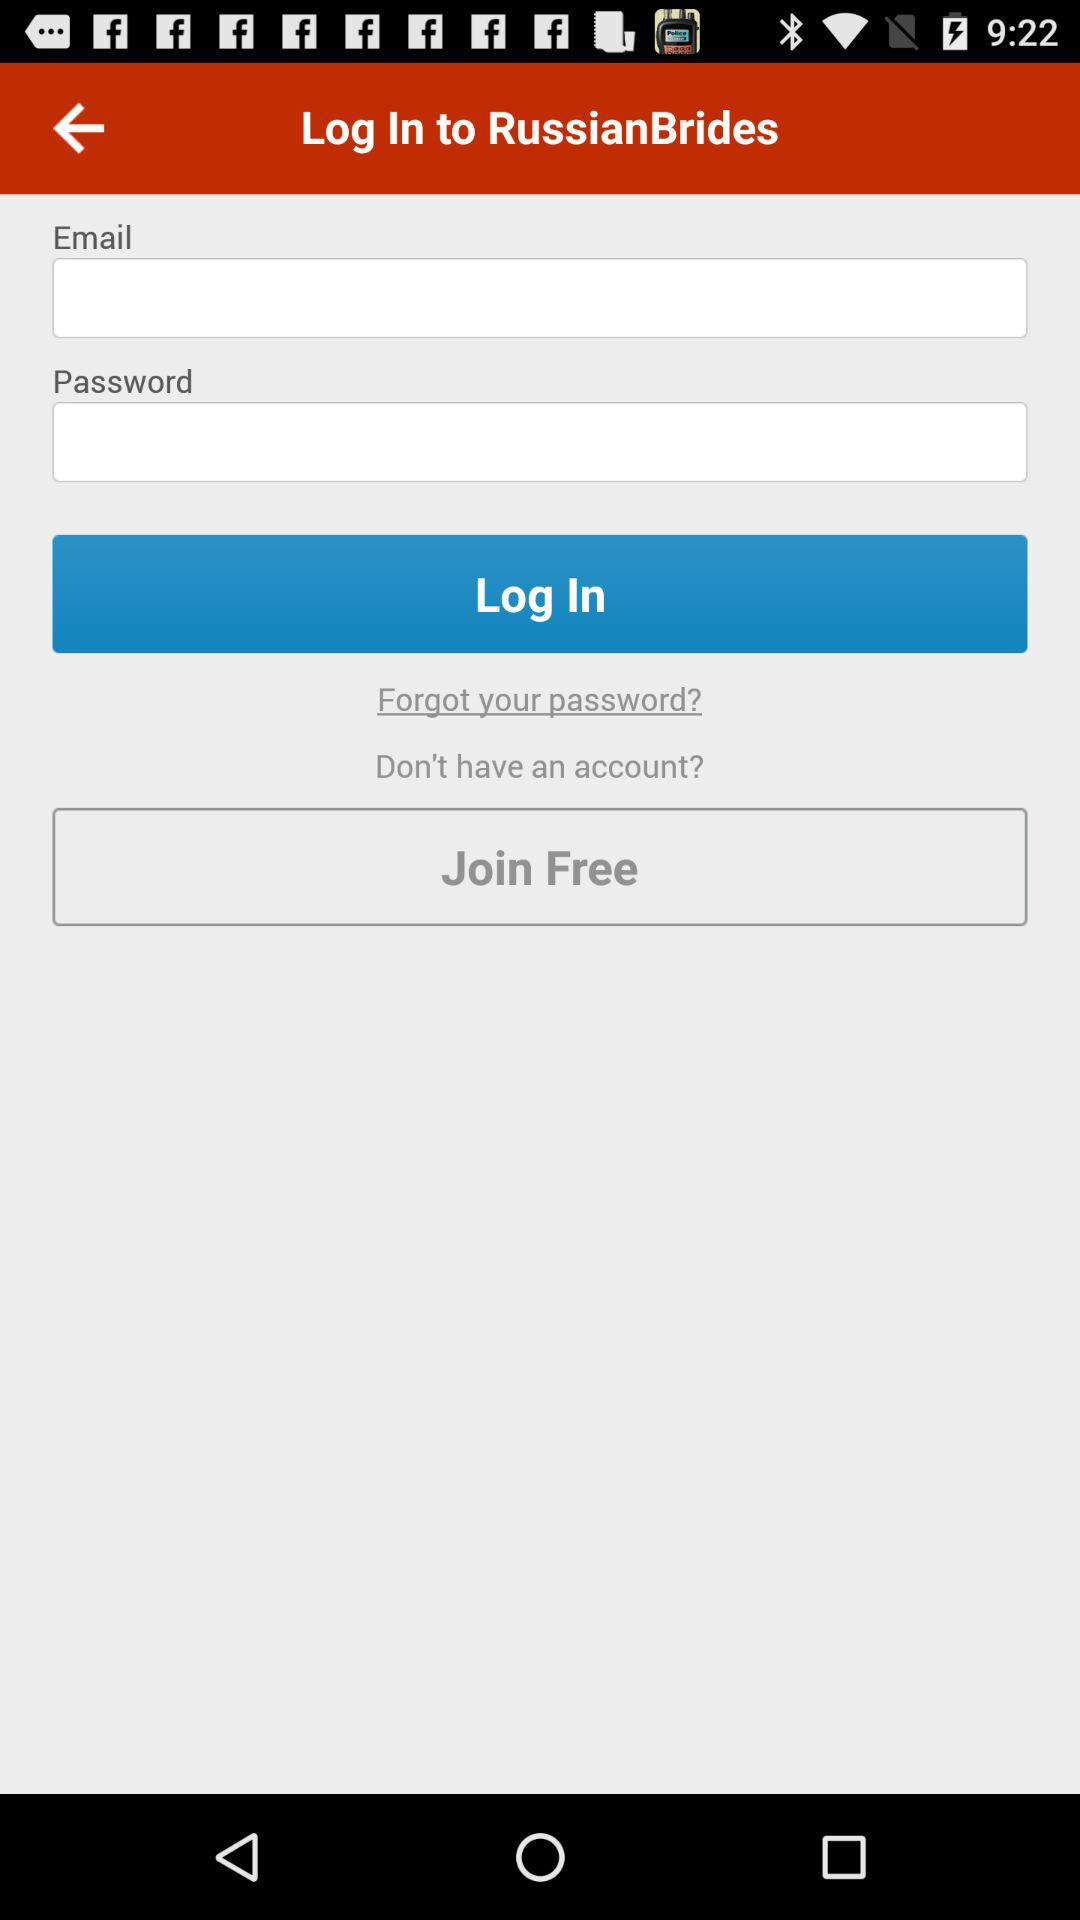What do we need in order to log in? You need an "Email" and a "Password" in order to log in. 